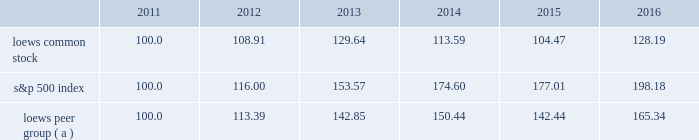Item 5 .
Market for the registrant 2019s common equity , related stockholder matters and issuer purchases of equity securities the following graph compares annual total return of our common stock , the standard & poor 2019s 500 composite stock index ( 201cs&p 500 index 201d ) and our peer group ( 201cloews peer group 201d ) for the five years ended december 31 , 2016 .
The graph assumes that the value of the investment in our common stock , the s&p 500 index and the loews peer group was $ 100 on december 31 , 2011 and that all dividends were reinvested. .
( a ) the loews peer group consists of the following companies that are industry competitors of our principal operating subsidiaries : chubb limited ( name change from ace limited after it acquired the chubb corporation on january 15 , 2016 ) , w.r .
Berkley corporation , the chubb corporation ( included through january 15 , 2016 when it was acquired by ace limited ) , energy transfer partners l.p. , ensco plc , the hartford financial services group , inc. , kinder morgan energy partners , l.p .
( included through november 26 , 2014 when it was acquired by kinder morgan inc. ) , noble corporation , spectra energy corp , transocean ltd .
And the travelers companies , inc .
Dividend information we have paid quarterly cash dividends in each year since 1967 .
Regular dividends of $ 0.0625 per share of loews common stock were paid in each calendar quarter of 2016 and 2015. .
What is the roi of an investment in s&p500 index from 2011 to 2012? 
Computations: ((116.00 - 100) / 100)
Answer: 0.16. Item 5 .
Market for the registrant 2019s common equity , related stockholder matters and issuer purchases of equity securities the following graph compares annual total return of our common stock , the standard & poor 2019s 500 composite stock index ( 201cs&p 500 index 201d ) and our peer group ( 201cloews peer group 201d ) for the five years ended december 31 , 2016 .
The graph assumes that the value of the investment in our common stock , the s&p 500 index and the loews peer group was $ 100 on december 31 , 2011 and that all dividends were reinvested. .
( a ) the loews peer group consists of the following companies that are industry competitors of our principal operating subsidiaries : chubb limited ( name change from ace limited after it acquired the chubb corporation on january 15 , 2016 ) , w.r .
Berkley corporation , the chubb corporation ( included through january 15 , 2016 when it was acquired by ace limited ) , energy transfer partners l.p. , ensco plc , the hartford financial services group , inc. , kinder morgan energy partners , l.p .
( included through november 26 , 2014 when it was acquired by kinder morgan inc. ) , noble corporation , spectra energy corp , transocean ltd .
And the travelers companies , inc .
Dividend information we have paid quarterly cash dividends in each year since 1967 .
Regular dividends of $ 0.0625 per share of loews common stock were paid in each calendar quarter of 2016 and 2015. .
In 2016 what was the ratio of the s&p 500 index to loews common stock overall growth from 2011 to 2016? 
Rationale: for every growth unit of loews common stock the s&p 500 index grew by 1.5
Computations: (198.18 / 165.34)
Answer: 1.19862. 